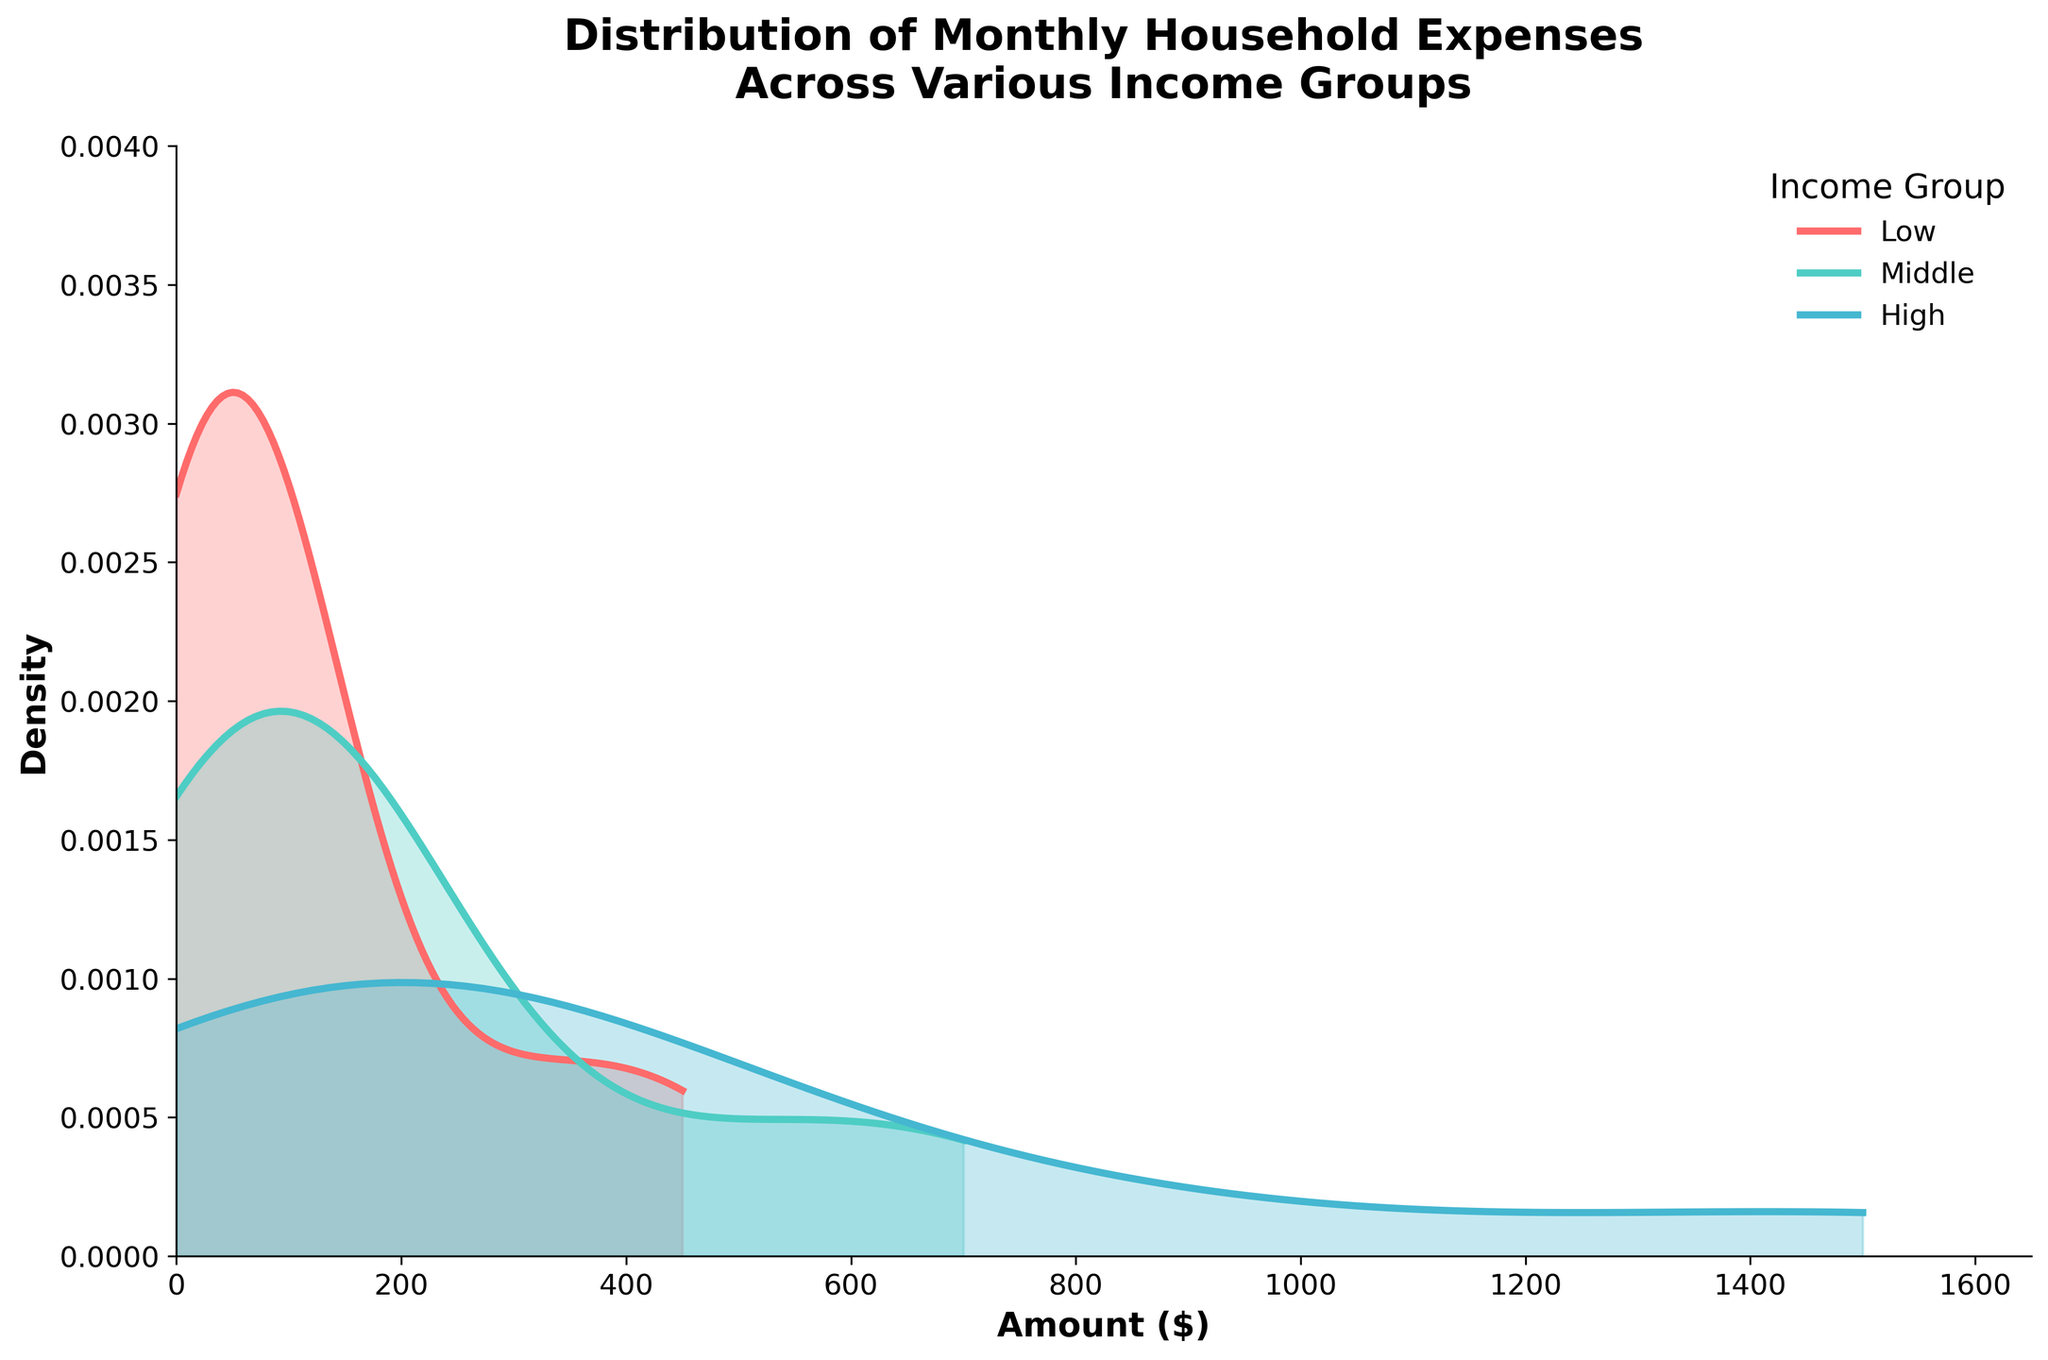What is the title of the figure? The title of the figure is displayed at the top. It describes the subject and focus of the visual representation.
Answer: Distribution of Monthly Household Expenses Across Various Income Groups Which income group has the widest distribution of expenses? By looking at the spread of the density curves, the group with the longest range on the x-axis indicates the widest distribution.
Answer: High What is the approximate maximum density value for the 'Low' income group? Examine the height of the density curve for the 'Low' income group and find the highest point on the y-axis.
Answer: 0.003 How do the density curves of the 'Middle' and 'High' income groups compare? Compare the shapes and spreads of the density curves for these two groups.
Answer: The 'High' group has a wider and higher-distributed curve than the 'Middle' group Which expense amount does the 'Middle' income group density peak around? Identify the x-axis position where the density curve for the 'Middle' income group reaches its highest point.
Answer: Approximately $700 Is there an overlap between the expenses distributions of the 'Low' and 'Middle' income groups? Observe if the density curves of the 'Low' and 'Middle' income groups intersect or overlap at any point.
Answer: Yes What can we infer about the spending patterns of the 'High' income group? Look at the range and spread of the density curve for the 'High' group, noting if it's concentrated or widespread.
Answer: They have a higher and broader range of expenses Between which expense amounts does the 'Low' income group distribution mainly lie? Check the x-axis range where the density curve for the 'Low' group has significant density.
Answer: Between $0 and approximately $600 What does the x-axis represent in this plot? The x-axis label describes what data is being plotted horizontally.
Answer: Amount ($) What can be inferred about the density of expenses between $0 and $200 among the different income groups? Compare how the density curves behave within the $0 to $200 range across all income groups.
Answer: Higher for 'Low' group, overlaps for 'Middle', lower for 'High' 